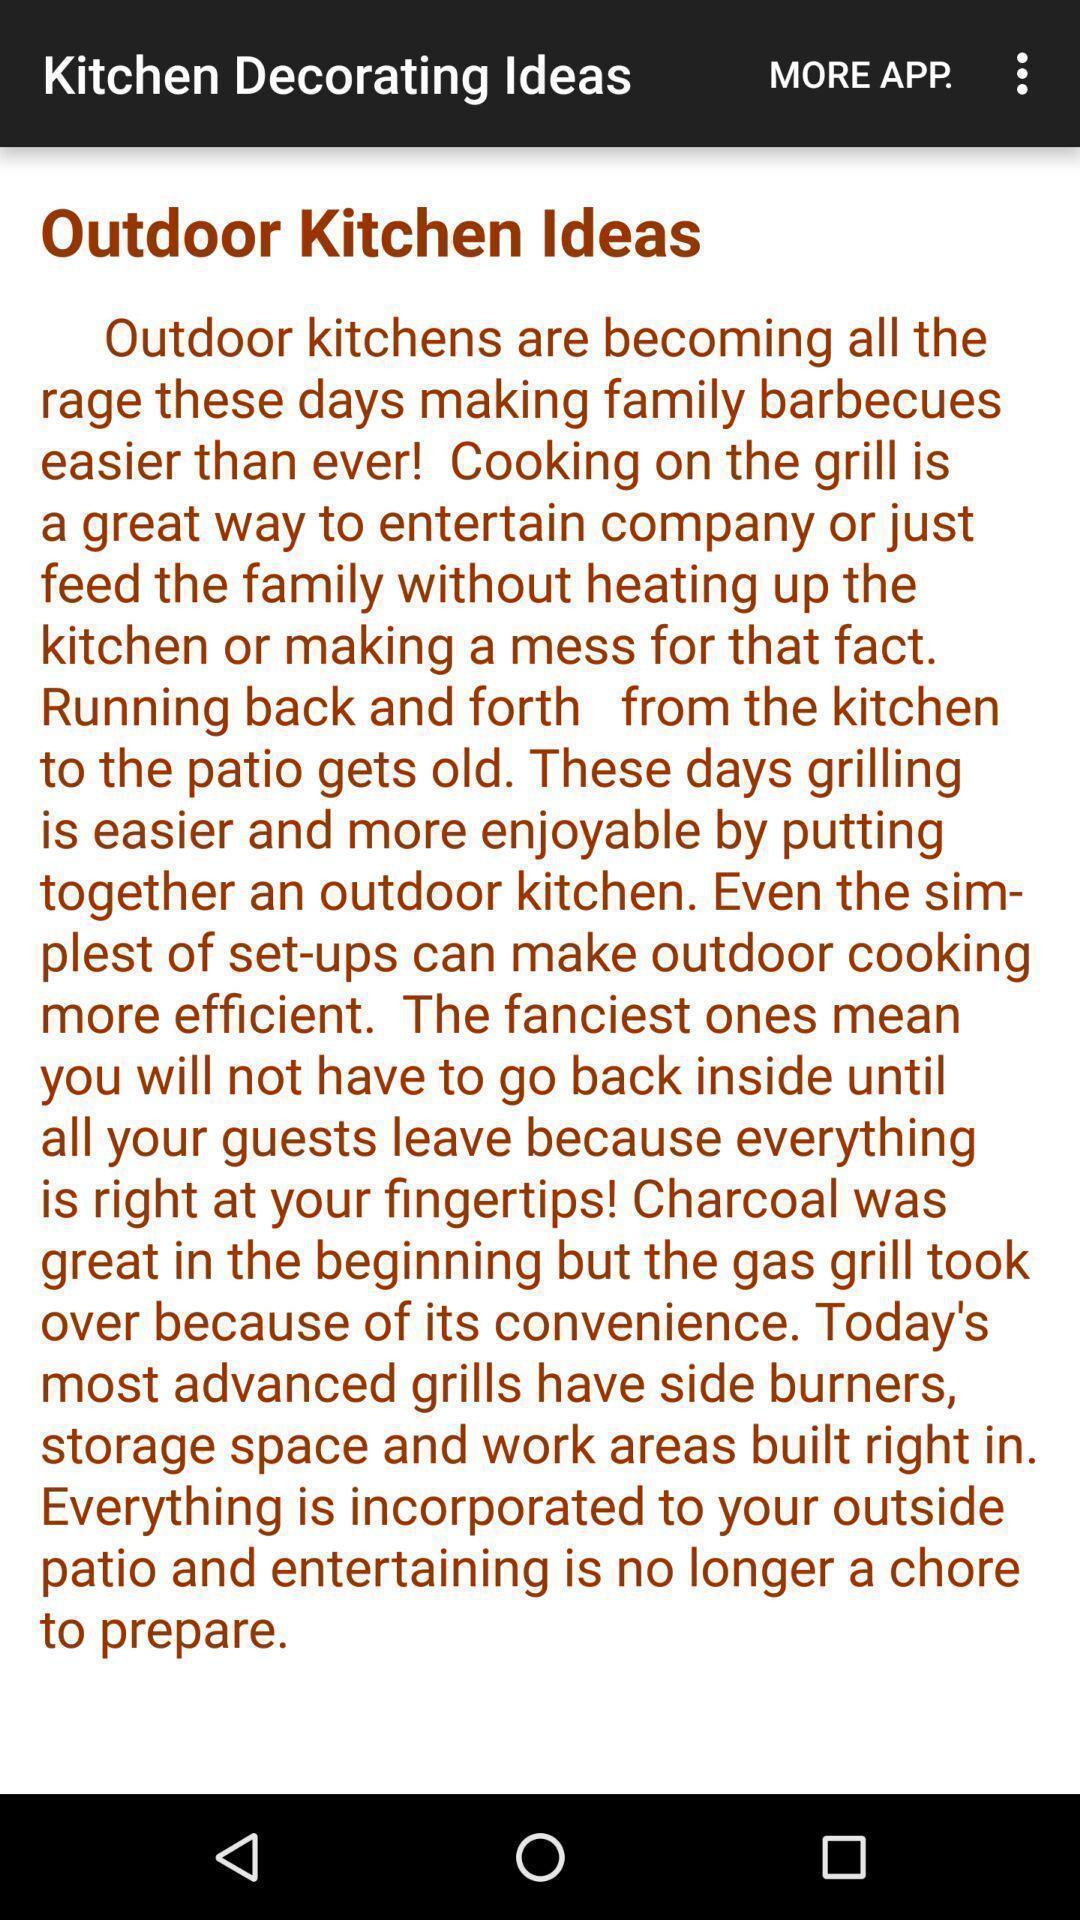Provide a textual representation of this image. Page displaying the kitchen decoration ideas. 